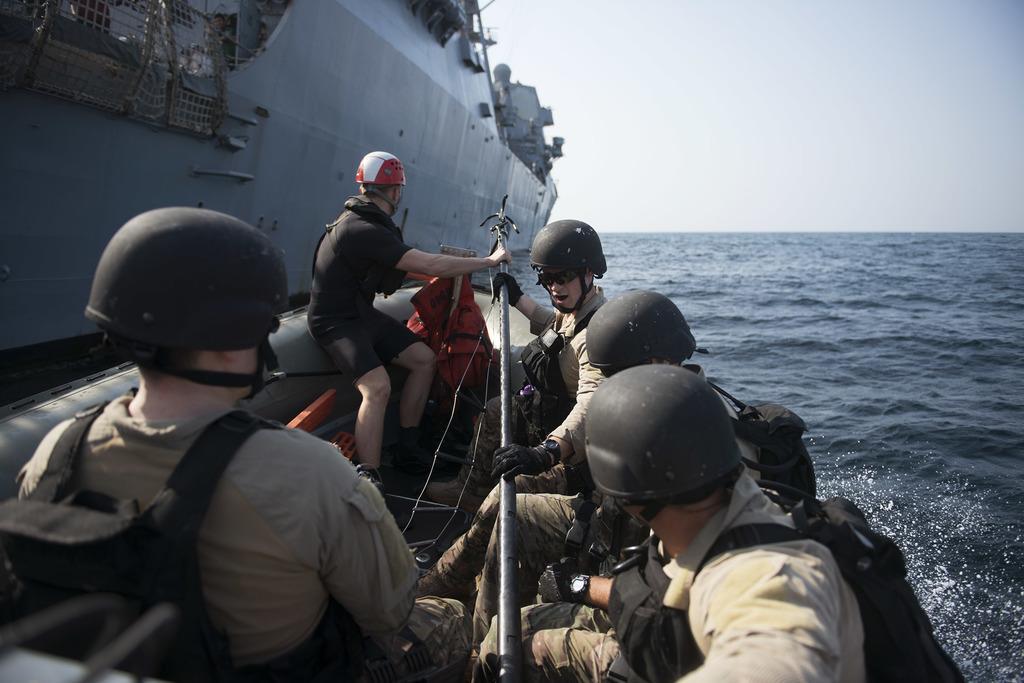Could you give a brief overview of what you see in this image? This image consists of a boat. There are so many persons sitting in the boat. They are wearing military dresses. There is water on the right side. There is sky at the top. 